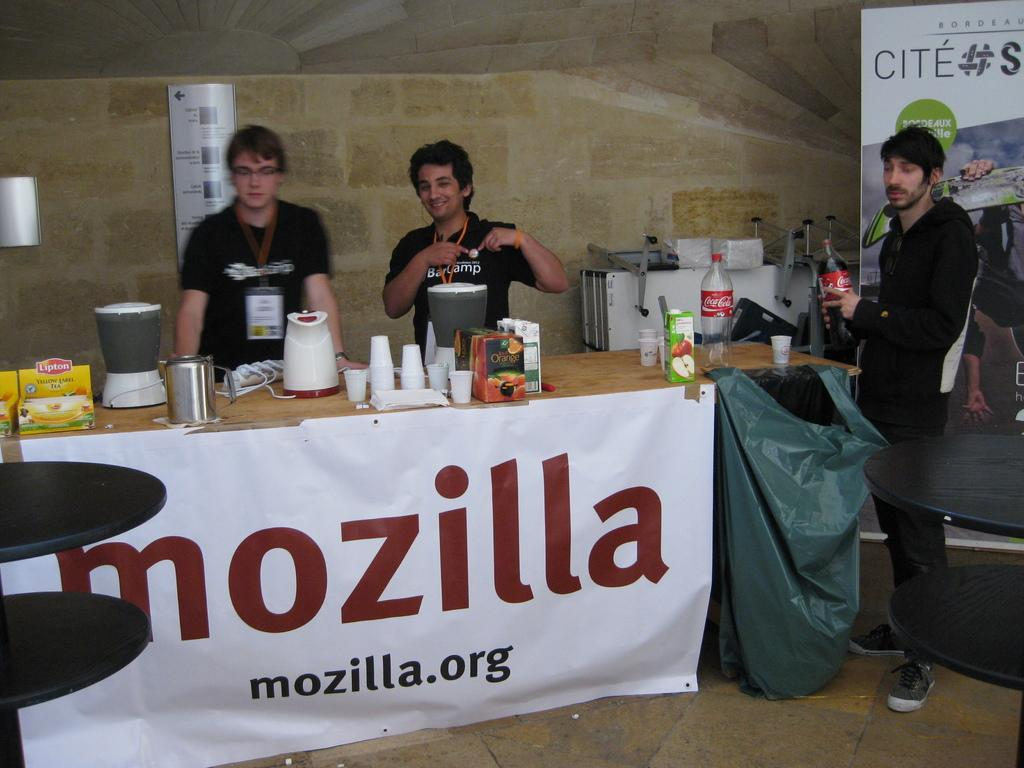What are the people doing in the image? The people are standing at a table. What objects can be seen on the table? There are grinders, glasses, food material, and water bottles on the table. What type of promotional materials are present in the image? There are banners and hoardings in the image. Where is the faucet located in the image? There is no faucet present in the image. What type of cap is being worn by the people in the image? The image does not show the people wearing any caps. 